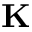Convert formula to latex. <formula><loc_0><loc_0><loc_500><loc_500>K</formula> 